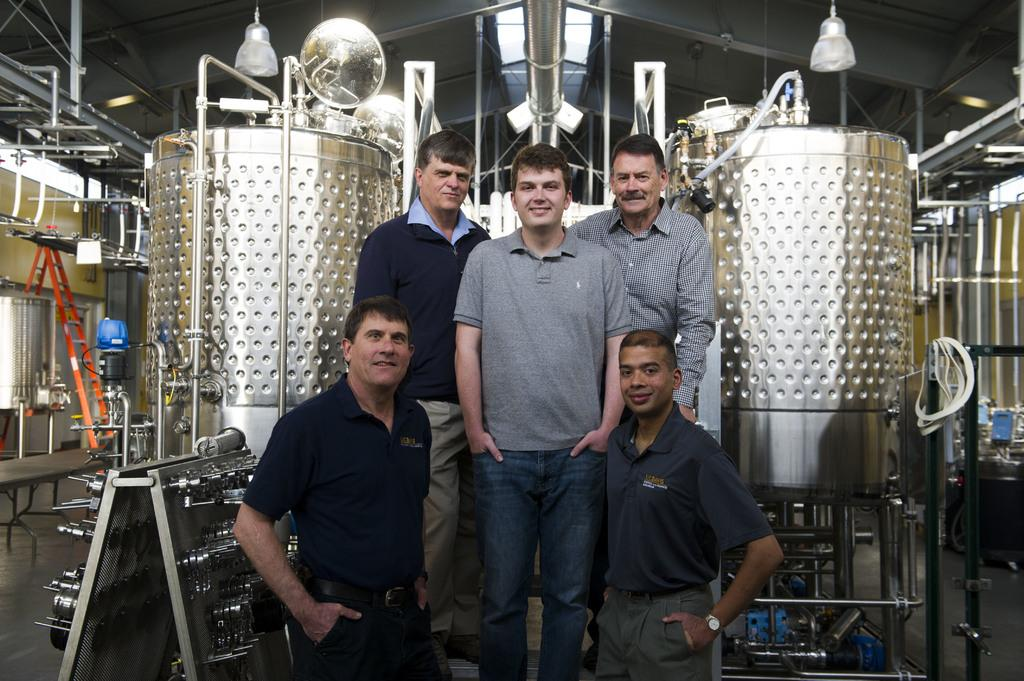What can be seen in the image involving people? There are people standing in the image. What objects are visible in the image that might be used for filtration? There are filters visible in the image. What can be seen in the image that might provide illumination? There are lights visible in the image. What type of infrastructure is visible in the image? There are pipes visible in the image. What type of structure is present in the image? There is a shed in the image. What type of ladder is present in the image? There is an orange-colored ladder in the image. What type of punishment is being administered to the mother in the image? There is no mother or punishment present in the image. What type of play is happening in the image? There is no play or indication of play happening in the image. 